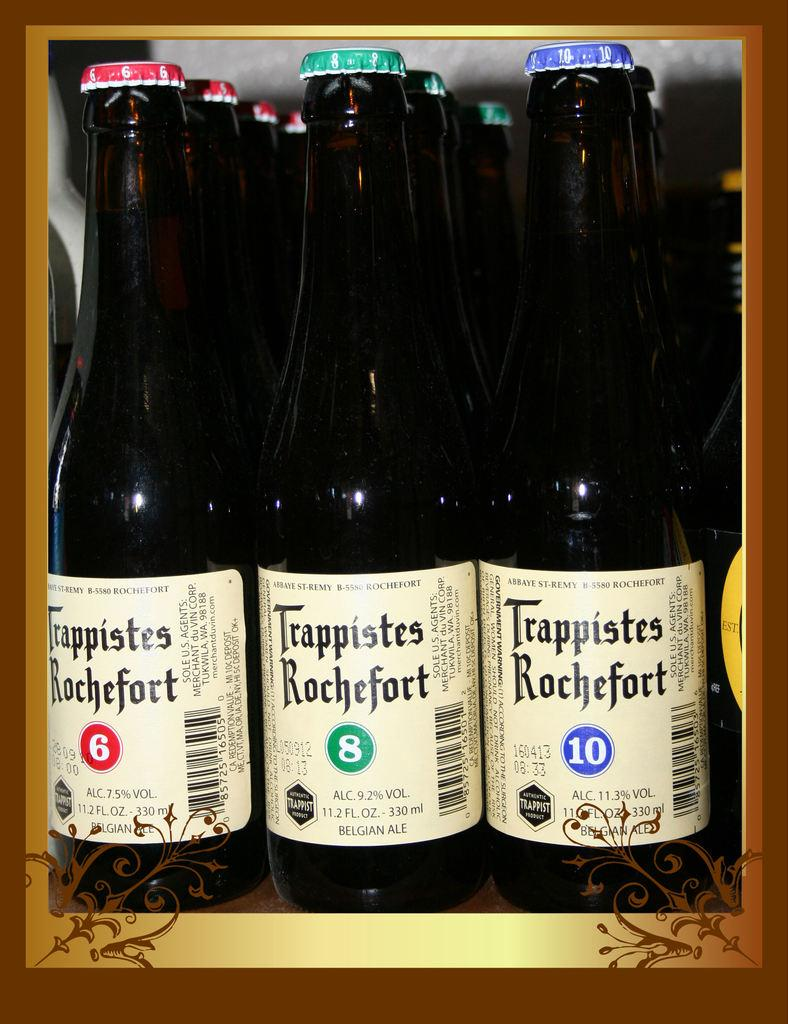Provide a one-sentence caption for the provided image. Three rows of Trappistes Rochefort beer placed by each other with numbers 6,8, and 10 on different ones. 